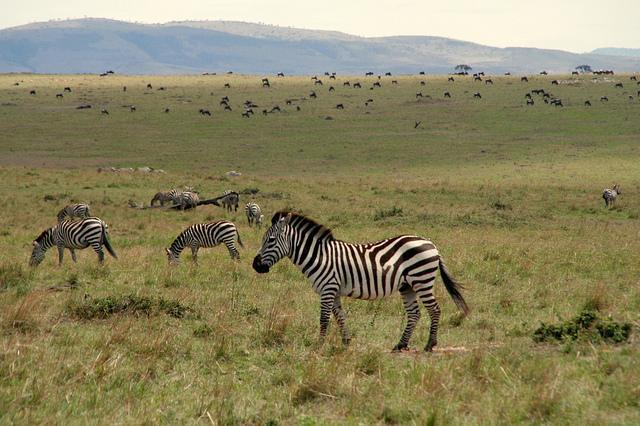What genus is this animal?
Choose the correct response and explain in the format: 'Answer: answer
Rationale: rationale.'
Options: Equus, algae, plant, bovidae. Answer: equus.
Rationale: Zebras are included in the genus equus along with horses. 